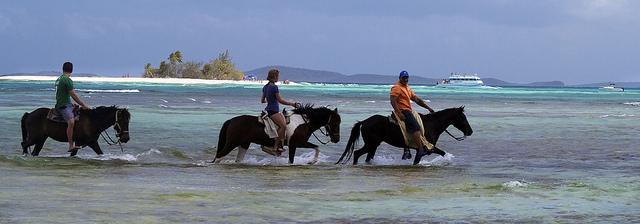Is this an indoor picture?
Concise answer only. No. What are the horses stepping in?
Give a very brief answer. Water. How many horses are in this photo?
Quick response, please. 3. 